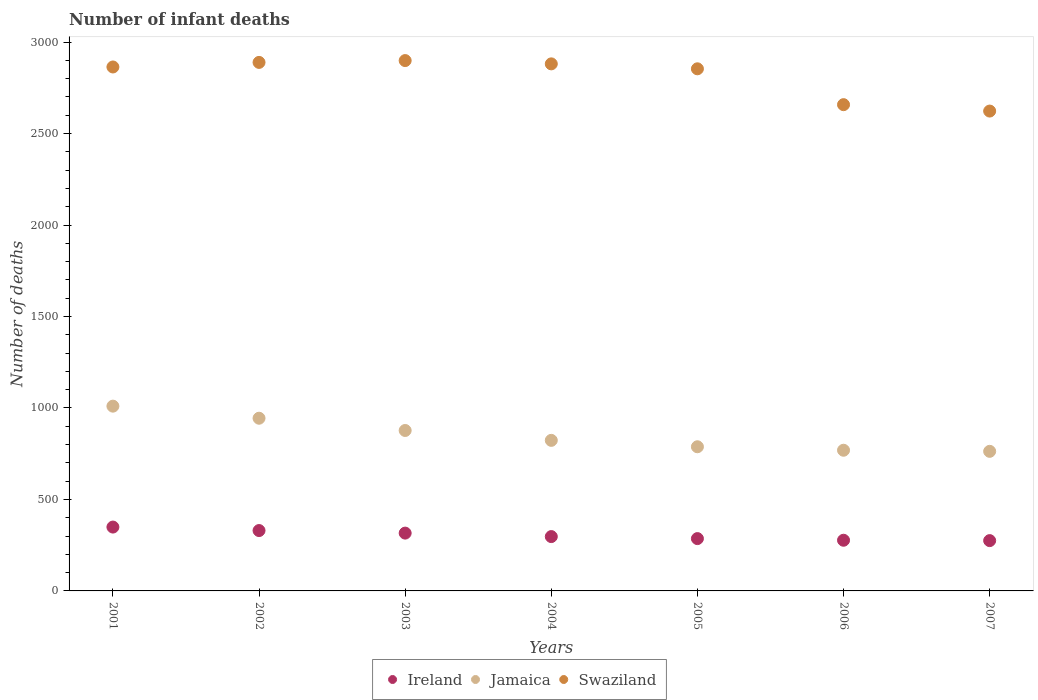How many different coloured dotlines are there?
Give a very brief answer. 3. Is the number of dotlines equal to the number of legend labels?
Provide a succinct answer. Yes. What is the number of infant deaths in Ireland in 2003?
Offer a very short reply. 316. Across all years, what is the maximum number of infant deaths in Swaziland?
Your answer should be very brief. 2899. Across all years, what is the minimum number of infant deaths in Swaziland?
Your answer should be very brief. 2623. In which year was the number of infant deaths in Ireland maximum?
Your answer should be very brief. 2001. What is the total number of infant deaths in Jamaica in the graph?
Keep it short and to the point. 5974. What is the difference between the number of infant deaths in Jamaica in 2002 and that in 2004?
Your answer should be compact. 121. What is the difference between the number of infant deaths in Ireland in 2001 and the number of infant deaths in Swaziland in 2005?
Your answer should be compact. -2505. What is the average number of infant deaths in Ireland per year?
Ensure brevity in your answer.  304.29. In the year 2005, what is the difference between the number of infant deaths in Ireland and number of infant deaths in Jamaica?
Your answer should be compact. -502. What is the ratio of the number of infant deaths in Ireland in 2003 to that in 2005?
Provide a short and direct response. 1.1. Is the difference between the number of infant deaths in Ireland in 2006 and 2007 greater than the difference between the number of infant deaths in Jamaica in 2006 and 2007?
Give a very brief answer. No. What is the difference between the highest and the lowest number of infant deaths in Ireland?
Keep it short and to the point. 74. In how many years, is the number of infant deaths in Swaziland greater than the average number of infant deaths in Swaziland taken over all years?
Provide a succinct answer. 5. Is the sum of the number of infant deaths in Jamaica in 2001 and 2003 greater than the maximum number of infant deaths in Swaziland across all years?
Your answer should be compact. No. Is the number of infant deaths in Jamaica strictly less than the number of infant deaths in Ireland over the years?
Ensure brevity in your answer.  No. How many dotlines are there?
Provide a succinct answer. 3. Are the values on the major ticks of Y-axis written in scientific E-notation?
Keep it short and to the point. No. Does the graph contain any zero values?
Make the answer very short. No. Does the graph contain grids?
Your response must be concise. No. Where does the legend appear in the graph?
Ensure brevity in your answer.  Bottom center. How many legend labels are there?
Your answer should be compact. 3. How are the legend labels stacked?
Offer a very short reply. Horizontal. What is the title of the graph?
Your answer should be very brief. Number of infant deaths. Does "Small states" appear as one of the legend labels in the graph?
Provide a short and direct response. No. What is the label or title of the Y-axis?
Give a very brief answer. Number of deaths. What is the Number of deaths of Ireland in 2001?
Give a very brief answer. 349. What is the Number of deaths of Jamaica in 2001?
Ensure brevity in your answer.  1010. What is the Number of deaths in Swaziland in 2001?
Offer a very short reply. 2864. What is the Number of deaths of Ireland in 2002?
Provide a short and direct response. 330. What is the Number of deaths of Jamaica in 2002?
Offer a very short reply. 944. What is the Number of deaths in Swaziland in 2002?
Offer a terse response. 2889. What is the Number of deaths in Ireland in 2003?
Offer a very short reply. 316. What is the Number of deaths in Jamaica in 2003?
Your answer should be very brief. 877. What is the Number of deaths in Swaziland in 2003?
Make the answer very short. 2899. What is the Number of deaths in Ireland in 2004?
Provide a succinct answer. 297. What is the Number of deaths in Jamaica in 2004?
Your answer should be very brief. 823. What is the Number of deaths in Swaziland in 2004?
Give a very brief answer. 2881. What is the Number of deaths of Ireland in 2005?
Ensure brevity in your answer.  286. What is the Number of deaths in Jamaica in 2005?
Make the answer very short. 788. What is the Number of deaths in Swaziland in 2005?
Provide a short and direct response. 2854. What is the Number of deaths in Ireland in 2006?
Ensure brevity in your answer.  277. What is the Number of deaths in Jamaica in 2006?
Your response must be concise. 769. What is the Number of deaths of Swaziland in 2006?
Offer a terse response. 2658. What is the Number of deaths in Ireland in 2007?
Make the answer very short. 275. What is the Number of deaths of Jamaica in 2007?
Provide a succinct answer. 763. What is the Number of deaths of Swaziland in 2007?
Your answer should be very brief. 2623. Across all years, what is the maximum Number of deaths in Ireland?
Provide a succinct answer. 349. Across all years, what is the maximum Number of deaths in Jamaica?
Give a very brief answer. 1010. Across all years, what is the maximum Number of deaths in Swaziland?
Your answer should be very brief. 2899. Across all years, what is the minimum Number of deaths in Ireland?
Keep it short and to the point. 275. Across all years, what is the minimum Number of deaths in Jamaica?
Ensure brevity in your answer.  763. Across all years, what is the minimum Number of deaths in Swaziland?
Offer a very short reply. 2623. What is the total Number of deaths in Ireland in the graph?
Ensure brevity in your answer.  2130. What is the total Number of deaths of Jamaica in the graph?
Provide a short and direct response. 5974. What is the total Number of deaths of Swaziland in the graph?
Offer a terse response. 1.97e+04. What is the difference between the Number of deaths in Ireland in 2001 and that in 2002?
Keep it short and to the point. 19. What is the difference between the Number of deaths of Jamaica in 2001 and that in 2002?
Give a very brief answer. 66. What is the difference between the Number of deaths of Jamaica in 2001 and that in 2003?
Your answer should be compact. 133. What is the difference between the Number of deaths in Swaziland in 2001 and that in 2003?
Offer a terse response. -35. What is the difference between the Number of deaths of Jamaica in 2001 and that in 2004?
Offer a very short reply. 187. What is the difference between the Number of deaths in Jamaica in 2001 and that in 2005?
Your answer should be very brief. 222. What is the difference between the Number of deaths in Ireland in 2001 and that in 2006?
Offer a very short reply. 72. What is the difference between the Number of deaths in Jamaica in 2001 and that in 2006?
Your response must be concise. 241. What is the difference between the Number of deaths of Swaziland in 2001 and that in 2006?
Make the answer very short. 206. What is the difference between the Number of deaths of Ireland in 2001 and that in 2007?
Offer a very short reply. 74. What is the difference between the Number of deaths of Jamaica in 2001 and that in 2007?
Your answer should be very brief. 247. What is the difference between the Number of deaths of Swaziland in 2001 and that in 2007?
Keep it short and to the point. 241. What is the difference between the Number of deaths of Ireland in 2002 and that in 2003?
Your answer should be very brief. 14. What is the difference between the Number of deaths in Jamaica in 2002 and that in 2003?
Offer a terse response. 67. What is the difference between the Number of deaths of Swaziland in 2002 and that in 2003?
Give a very brief answer. -10. What is the difference between the Number of deaths in Ireland in 2002 and that in 2004?
Make the answer very short. 33. What is the difference between the Number of deaths of Jamaica in 2002 and that in 2004?
Your response must be concise. 121. What is the difference between the Number of deaths of Ireland in 2002 and that in 2005?
Keep it short and to the point. 44. What is the difference between the Number of deaths of Jamaica in 2002 and that in 2005?
Make the answer very short. 156. What is the difference between the Number of deaths of Ireland in 2002 and that in 2006?
Your response must be concise. 53. What is the difference between the Number of deaths of Jamaica in 2002 and that in 2006?
Provide a succinct answer. 175. What is the difference between the Number of deaths in Swaziland in 2002 and that in 2006?
Provide a succinct answer. 231. What is the difference between the Number of deaths in Jamaica in 2002 and that in 2007?
Provide a short and direct response. 181. What is the difference between the Number of deaths of Swaziland in 2002 and that in 2007?
Give a very brief answer. 266. What is the difference between the Number of deaths of Jamaica in 2003 and that in 2004?
Ensure brevity in your answer.  54. What is the difference between the Number of deaths in Ireland in 2003 and that in 2005?
Keep it short and to the point. 30. What is the difference between the Number of deaths in Jamaica in 2003 and that in 2005?
Make the answer very short. 89. What is the difference between the Number of deaths of Swaziland in 2003 and that in 2005?
Make the answer very short. 45. What is the difference between the Number of deaths of Jamaica in 2003 and that in 2006?
Your answer should be compact. 108. What is the difference between the Number of deaths in Swaziland in 2003 and that in 2006?
Your answer should be very brief. 241. What is the difference between the Number of deaths in Ireland in 2003 and that in 2007?
Give a very brief answer. 41. What is the difference between the Number of deaths in Jamaica in 2003 and that in 2007?
Your answer should be very brief. 114. What is the difference between the Number of deaths of Swaziland in 2003 and that in 2007?
Provide a succinct answer. 276. What is the difference between the Number of deaths of Ireland in 2004 and that in 2005?
Make the answer very short. 11. What is the difference between the Number of deaths in Ireland in 2004 and that in 2006?
Your answer should be compact. 20. What is the difference between the Number of deaths in Jamaica in 2004 and that in 2006?
Make the answer very short. 54. What is the difference between the Number of deaths in Swaziland in 2004 and that in 2006?
Your answer should be compact. 223. What is the difference between the Number of deaths in Ireland in 2004 and that in 2007?
Make the answer very short. 22. What is the difference between the Number of deaths of Jamaica in 2004 and that in 2007?
Provide a succinct answer. 60. What is the difference between the Number of deaths in Swaziland in 2004 and that in 2007?
Provide a short and direct response. 258. What is the difference between the Number of deaths in Ireland in 2005 and that in 2006?
Your response must be concise. 9. What is the difference between the Number of deaths in Swaziland in 2005 and that in 2006?
Your answer should be very brief. 196. What is the difference between the Number of deaths in Swaziland in 2005 and that in 2007?
Give a very brief answer. 231. What is the difference between the Number of deaths in Ireland in 2006 and that in 2007?
Provide a succinct answer. 2. What is the difference between the Number of deaths of Swaziland in 2006 and that in 2007?
Provide a succinct answer. 35. What is the difference between the Number of deaths in Ireland in 2001 and the Number of deaths in Jamaica in 2002?
Make the answer very short. -595. What is the difference between the Number of deaths of Ireland in 2001 and the Number of deaths of Swaziland in 2002?
Give a very brief answer. -2540. What is the difference between the Number of deaths of Jamaica in 2001 and the Number of deaths of Swaziland in 2002?
Your answer should be very brief. -1879. What is the difference between the Number of deaths in Ireland in 2001 and the Number of deaths in Jamaica in 2003?
Keep it short and to the point. -528. What is the difference between the Number of deaths of Ireland in 2001 and the Number of deaths of Swaziland in 2003?
Your answer should be very brief. -2550. What is the difference between the Number of deaths in Jamaica in 2001 and the Number of deaths in Swaziland in 2003?
Your answer should be compact. -1889. What is the difference between the Number of deaths in Ireland in 2001 and the Number of deaths in Jamaica in 2004?
Provide a succinct answer. -474. What is the difference between the Number of deaths of Ireland in 2001 and the Number of deaths of Swaziland in 2004?
Offer a very short reply. -2532. What is the difference between the Number of deaths of Jamaica in 2001 and the Number of deaths of Swaziland in 2004?
Keep it short and to the point. -1871. What is the difference between the Number of deaths in Ireland in 2001 and the Number of deaths in Jamaica in 2005?
Keep it short and to the point. -439. What is the difference between the Number of deaths of Ireland in 2001 and the Number of deaths of Swaziland in 2005?
Ensure brevity in your answer.  -2505. What is the difference between the Number of deaths of Jamaica in 2001 and the Number of deaths of Swaziland in 2005?
Ensure brevity in your answer.  -1844. What is the difference between the Number of deaths of Ireland in 2001 and the Number of deaths of Jamaica in 2006?
Offer a very short reply. -420. What is the difference between the Number of deaths of Ireland in 2001 and the Number of deaths of Swaziland in 2006?
Keep it short and to the point. -2309. What is the difference between the Number of deaths of Jamaica in 2001 and the Number of deaths of Swaziland in 2006?
Your response must be concise. -1648. What is the difference between the Number of deaths of Ireland in 2001 and the Number of deaths of Jamaica in 2007?
Offer a terse response. -414. What is the difference between the Number of deaths in Ireland in 2001 and the Number of deaths in Swaziland in 2007?
Ensure brevity in your answer.  -2274. What is the difference between the Number of deaths of Jamaica in 2001 and the Number of deaths of Swaziland in 2007?
Your answer should be compact. -1613. What is the difference between the Number of deaths in Ireland in 2002 and the Number of deaths in Jamaica in 2003?
Make the answer very short. -547. What is the difference between the Number of deaths of Ireland in 2002 and the Number of deaths of Swaziland in 2003?
Offer a very short reply. -2569. What is the difference between the Number of deaths of Jamaica in 2002 and the Number of deaths of Swaziland in 2003?
Provide a succinct answer. -1955. What is the difference between the Number of deaths of Ireland in 2002 and the Number of deaths of Jamaica in 2004?
Provide a short and direct response. -493. What is the difference between the Number of deaths in Ireland in 2002 and the Number of deaths in Swaziland in 2004?
Your response must be concise. -2551. What is the difference between the Number of deaths in Jamaica in 2002 and the Number of deaths in Swaziland in 2004?
Offer a very short reply. -1937. What is the difference between the Number of deaths of Ireland in 2002 and the Number of deaths of Jamaica in 2005?
Your answer should be very brief. -458. What is the difference between the Number of deaths of Ireland in 2002 and the Number of deaths of Swaziland in 2005?
Offer a very short reply. -2524. What is the difference between the Number of deaths of Jamaica in 2002 and the Number of deaths of Swaziland in 2005?
Provide a short and direct response. -1910. What is the difference between the Number of deaths of Ireland in 2002 and the Number of deaths of Jamaica in 2006?
Provide a succinct answer. -439. What is the difference between the Number of deaths of Ireland in 2002 and the Number of deaths of Swaziland in 2006?
Your answer should be compact. -2328. What is the difference between the Number of deaths in Jamaica in 2002 and the Number of deaths in Swaziland in 2006?
Your response must be concise. -1714. What is the difference between the Number of deaths of Ireland in 2002 and the Number of deaths of Jamaica in 2007?
Keep it short and to the point. -433. What is the difference between the Number of deaths of Ireland in 2002 and the Number of deaths of Swaziland in 2007?
Your answer should be very brief. -2293. What is the difference between the Number of deaths in Jamaica in 2002 and the Number of deaths in Swaziland in 2007?
Ensure brevity in your answer.  -1679. What is the difference between the Number of deaths in Ireland in 2003 and the Number of deaths in Jamaica in 2004?
Your answer should be compact. -507. What is the difference between the Number of deaths of Ireland in 2003 and the Number of deaths of Swaziland in 2004?
Your response must be concise. -2565. What is the difference between the Number of deaths in Jamaica in 2003 and the Number of deaths in Swaziland in 2004?
Your answer should be compact. -2004. What is the difference between the Number of deaths of Ireland in 2003 and the Number of deaths of Jamaica in 2005?
Ensure brevity in your answer.  -472. What is the difference between the Number of deaths in Ireland in 2003 and the Number of deaths in Swaziland in 2005?
Provide a short and direct response. -2538. What is the difference between the Number of deaths in Jamaica in 2003 and the Number of deaths in Swaziland in 2005?
Provide a short and direct response. -1977. What is the difference between the Number of deaths of Ireland in 2003 and the Number of deaths of Jamaica in 2006?
Keep it short and to the point. -453. What is the difference between the Number of deaths in Ireland in 2003 and the Number of deaths in Swaziland in 2006?
Provide a succinct answer. -2342. What is the difference between the Number of deaths in Jamaica in 2003 and the Number of deaths in Swaziland in 2006?
Your response must be concise. -1781. What is the difference between the Number of deaths in Ireland in 2003 and the Number of deaths in Jamaica in 2007?
Your answer should be compact. -447. What is the difference between the Number of deaths in Ireland in 2003 and the Number of deaths in Swaziland in 2007?
Ensure brevity in your answer.  -2307. What is the difference between the Number of deaths in Jamaica in 2003 and the Number of deaths in Swaziland in 2007?
Offer a terse response. -1746. What is the difference between the Number of deaths in Ireland in 2004 and the Number of deaths in Jamaica in 2005?
Make the answer very short. -491. What is the difference between the Number of deaths of Ireland in 2004 and the Number of deaths of Swaziland in 2005?
Your answer should be very brief. -2557. What is the difference between the Number of deaths of Jamaica in 2004 and the Number of deaths of Swaziland in 2005?
Keep it short and to the point. -2031. What is the difference between the Number of deaths of Ireland in 2004 and the Number of deaths of Jamaica in 2006?
Give a very brief answer. -472. What is the difference between the Number of deaths in Ireland in 2004 and the Number of deaths in Swaziland in 2006?
Make the answer very short. -2361. What is the difference between the Number of deaths of Jamaica in 2004 and the Number of deaths of Swaziland in 2006?
Give a very brief answer. -1835. What is the difference between the Number of deaths of Ireland in 2004 and the Number of deaths of Jamaica in 2007?
Provide a short and direct response. -466. What is the difference between the Number of deaths of Ireland in 2004 and the Number of deaths of Swaziland in 2007?
Offer a terse response. -2326. What is the difference between the Number of deaths in Jamaica in 2004 and the Number of deaths in Swaziland in 2007?
Provide a succinct answer. -1800. What is the difference between the Number of deaths of Ireland in 2005 and the Number of deaths of Jamaica in 2006?
Offer a very short reply. -483. What is the difference between the Number of deaths in Ireland in 2005 and the Number of deaths in Swaziland in 2006?
Keep it short and to the point. -2372. What is the difference between the Number of deaths of Jamaica in 2005 and the Number of deaths of Swaziland in 2006?
Offer a terse response. -1870. What is the difference between the Number of deaths of Ireland in 2005 and the Number of deaths of Jamaica in 2007?
Offer a terse response. -477. What is the difference between the Number of deaths of Ireland in 2005 and the Number of deaths of Swaziland in 2007?
Provide a succinct answer. -2337. What is the difference between the Number of deaths of Jamaica in 2005 and the Number of deaths of Swaziland in 2007?
Keep it short and to the point. -1835. What is the difference between the Number of deaths in Ireland in 2006 and the Number of deaths in Jamaica in 2007?
Your answer should be very brief. -486. What is the difference between the Number of deaths of Ireland in 2006 and the Number of deaths of Swaziland in 2007?
Your answer should be very brief. -2346. What is the difference between the Number of deaths in Jamaica in 2006 and the Number of deaths in Swaziland in 2007?
Offer a very short reply. -1854. What is the average Number of deaths of Ireland per year?
Ensure brevity in your answer.  304.29. What is the average Number of deaths of Jamaica per year?
Offer a terse response. 853.43. What is the average Number of deaths of Swaziland per year?
Provide a succinct answer. 2809.71. In the year 2001, what is the difference between the Number of deaths in Ireland and Number of deaths in Jamaica?
Make the answer very short. -661. In the year 2001, what is the difference between the Number of deaths in Ireland and Number of deaths in Swaziland?
Provide a succinct answer. -2515. In the year 2001, what is the difference between the Number of deaths of Jamaica and Number of deaths of Swaziland?
Your response must be concise. -1854. In the year 2002, what is the difference between the Number of deaths of Ireland and Number of deaths of Jamaica?
Offer a terse response. -614. In the year 2002, what is the difference between the Number of deaths in Ireland and Number of deaths in Swaziland?
Your answer should be compact. -2559. In the year 2002, what is the difference between the Number of deaths of Jamaica and Number of deaths of Swaziland?
Offer a very short reply. -1945. In the year 2003, what is the difference between the Number of deaths of Ireland and Number of deaths of Jamaica?
Give a very brief answer. -561. In the year 2003, what is the difference between the Number of deaths in Ireland and Number of deaths in Swaziland?
Make the answer very short. -2583. In the year 2003, what is the difference between the Number of deaths of Jamaica and Number of deaths of Swaziland?
Offer a very short reply. -2022. In the year 2004, what is the difference between the Number of deaths of Ireland and Number of deaths of Jamaica?
Ensure brevity in your answer.  -526. In the year 2004, what is the difference between the Number of deaths of Ireland and Number of deaths of Swaziland?
Provide a short and direct response. -2584. In the year 2004, what is the difference between the Number of deaths in Jamaica and Number of deaths in Swaziland?
Provide a succinct answer. -2058. In the year 2005, what is the difference between the Number of deaths of Ireland and Number of deaths of Jamaica?
Offer a very short reply. -502. In the year 2005, what is the difference between the Number of deaths of Ireland and Number of deaths of Swaziland?
Your answer should be compact. -2568. In the year 2005, what is the difference between the Number of deaths of Jamaica and Number of deaths of Swaziland?
Provide a succinct answer. -2066. In the year 2006, what is the difference between the Number of deaths in Ireland and Number of deaths in Jamaica?
Your answer should be compact. -492. In the year 2006, what is the difference between the Number of deaths in Ireland and Number of deaths in Swaziland?
Your answer should be very brief. -2381. In the year 2006, what is the difference between the Number of deaths in Jamaica and Number of deaths in Swaziland?
Your answer should be compact. -1889. In the year 2007, what is the difference between the Number of deaths of Ireland and Number of deaths of Jamaica?
Offer a terse response. -488. In the year 2007, what is the difference between the Number of deaths of Ireland and Number of deaths of Swaziland?
Your response must be concise. -2348. In the year 2007, what is the difference between the Number of deaths of Jamaica and Number of deaths of Swaziland?
Ensure brevity in your answer.  -1860. What is the ratio of the Number of deaths in Ireland in 2001 to that in 2002?
Your answer should be very brief. 1.06. What is the ratio of the Number of deaths of Jamaica in 2001 to that in 2002?
Your answer should be compact. 1.07. What is the ratio of the Number of deaths of Swaziland in 2001 to that in 2002?
Your answer should be very brief. 0.99. What is the ratio of the Number of deaths in Ireland in 2001 to that in 2003?
Give a very brief answer. 1.1. What is the ratio of the Number of deaths of Jamaica in 2001 to that in 2003?
Offer a terse response. 1.15. What is the ratio of the Number of deaths of Swaziland in 2001 to that in 2003?
Your answer should be compact. 0.99. What is the ratio of the Number of deaths of Ireland in 2001 to that in 2004?
Provide a short and direct response. 1.18. What is the ratio of the Number of deaths of Jamaica in 2001 to that in 2004?
Your response must be concise. 1.23. What is the ratio of the Number of deaths of Swaziland in 2001 to that in 2004?
Keep it short and to the point. 0.99. What is the ratio of the Number of deaths of Ireland in 2001 to that in 2005?
Your answer should be compact. 1.22. What is the ratio of the Number of deaths of Jamaica in 2001 to that in 2005?
Keep it short and to the point. 1.28. What is the ratio of the Number of deaths in Ireland in 2001 to that in 2006?
Keep it short and to the point. 1.26. What is the ratio of the Number of deaths in Jamaica in 2001 to that in 2006?
Keep it short and to the point. 1.31. What is the ratio of the Number of deaths in Swaziland in 2001 to that in 2006?
Your response must be concise. 1.08. What is the ratio of the Number of deaths of Ireland in 2001 to that in 2007?
Offer a very short reply. 1.27. What is the ratio of the Number of deaths of Jamaica in 2001 to that in 2007?
Make the answer very short. 1.32. What is the ratio of the Number of deaths of Swaziland in 2001 to that in 2007?
Provide a succinct answer. 1.09. What is the ratio of the Number of deaths of Ireland in 2002 to that in 2003?
Your response must be concise. 1.04. What is the ratio of the Number of deaths in Jamaica in 2002 to that in 2003?
Make the answer very short. 1.08. What is the ratio of the Number of deaths in Ireland in 2002 to that in 2004?
Your response must be concise. 1.11. What is the ratio of the Number of deaths in Jamaica in 2002 to that in 2004?
Make the answer very short. 1.15. What is the ratio of the Number of deaths of Swaziland in 2002 to that in 2004?
Ensure brevity in your answer.  1. What is the ratio of the Number of deaths in Ireland in 2002 to that in 2005?
Make the answer very short. 1.15. What is the ratio of the Number of deaths of Jamaica in 2002 to that in 2005?
Ensure brevity in your answer.  1.2. What is the ratio of the Number of deaths in Swaziland in 2002 to that in 2005?
Provide a short and direct response. 1.01. What is the ratio of the Number of deaths of Ireland in 2002 to that in 2006?
Your answer should be very brief. 1.19. What is the ratio of the Number of deaths in Jamaica in 2002 to that in 2006?
Your answer should be compact. 1.23. What is the ratio of the Number of deaths of Swaziland in 2002 to that in 2006?
Offer a terse response. 1.09. What is the ratio of the Number of deaths in Jamaica in 2002 to that in 2007?
Provide a succinct answer. 1.24. What is the ratio of the Number of deaths in Swaziland in 2002 to that in 2007?
Offer a very short reply. 1.1. What is the ratio of the Number of deaths in Ireland in 2003 to that in 2004?
Your response must be concise. 1.06. What is the ratio of the Number of deaths in Jamaica in 2003 to that in 2004?
Provide a succinct answer. 1.07. What is the ratio of the Number of deaths of Swaziland in 2003 to that in 2004?
Offer a terse response. 1.01. What is the ratio of the Number of deaths in Ireland in 2003 to that in 2005?
Provide a short and direct response. 1.1. What is the ratio of the Number of deaths of Jamaica in 2003 to that in 2005?
Ensure brevity in your answer.  1.11. What is the ratio of the Number of deaths of Swaziland in 2003 to that in 2005?
Your response must be concise. 1.02. What is the ratio of the Number of deaths in Ireland in 2003 to that in 2006?
Make the answer very short. 1.14. What is the ratio of the Number of deaths in Jamaica in 2003 to that in 2006?
Give a very brief answer. 1.14. What is the ratio of the Number of deaths in Swaziland in 2003 to that in 2006?
Offer a terse response. 1.09. What is the ratio of the Number of deaths in Ireland in 2003 to that in 2007?
Ensure brevity in your answer.  1.15. What is the ratio of the Number of deaths in Jamaica in 2003 to that in 2007?
Your answer should be compact. 1.15. What is the ratio of the Number of deaths of Swaziland in 2003 to that in 2007?
Provide a short and direct response. 1.11. What is the ratio of the Number of deaths in Jamaica in 2004 to that in 2005?
Make the answer very short. 1.04. What is the ratio of the Number of deaths in Swaziland in 2004 to that in 2005?
Your answer should be very brief. 1.01. What is the ratio of the Number of deaths of Ireland in 2004 to that in 2006?
Your answer should be compact. 1.07. What is the ratio of the Number of deaths of Jamaica in 2004 to that in 2006?
Keep it short and to the point. 1.07. What is the ratio of the Number of deaths of Swaziland in 2004 to that in 2006?
Offer a very short reply. 1.08. What is the ratio of the Number of deaths of Jamaica in 2004 to that in 2007?
Offer a terse response. 1.08. What is the ratio of the Number of deaths in Swaziland in 2004 to that in 2007?
Provide a short and direct response. 1.1. What is the ratio of the Number of deaths of Ireland in 2005 to that in 2006?
Offer a very short reply. 1.03. What is the ratio of the Number of deaths in Jamaica in 2005 to that in 2006?
Provide a short and direct response. 1.02. What is the ratio of the Number of deaths in Swaziland in 2005 to that in 2006?
Your response must be concise. 1.07. What is the ratio of the Number of deaths in Jamaica in 2005 to that in 2007?
Offer a very short reply. 1.03. What is the ratio of the Number of deaths in Swaziland in 2005 to that in 2007?
Your answer should be very brief. 1.09. What is the ratio of the Number of deaths in Ireland in 2006 to that in 2007?
Give a very brief answer. 1.01. What is the ratio of the Number of deaths of Jamaica in 2006 to that in 2007?
Your answer should be compact. 1.01. What is the ratio of the Number of deaths of Swaziland in 2006 to that in 2007?
Your answer should be very brief. 1.01. What is the difference between the highest and the second highest Number of deaths of Ireland?
Your response must be concise. 19. What is the difference between the highest and the second highest Number of deaths in Jamaica?
Give a very brief answer. 66. What is the difference between the highest and the lowest Number of deaths in Jamaica?
Offer a very short reply. 247. What is the difference between the highest and the lowest Number of deaths in Swaziland?
Your answer should be compact. 276. 